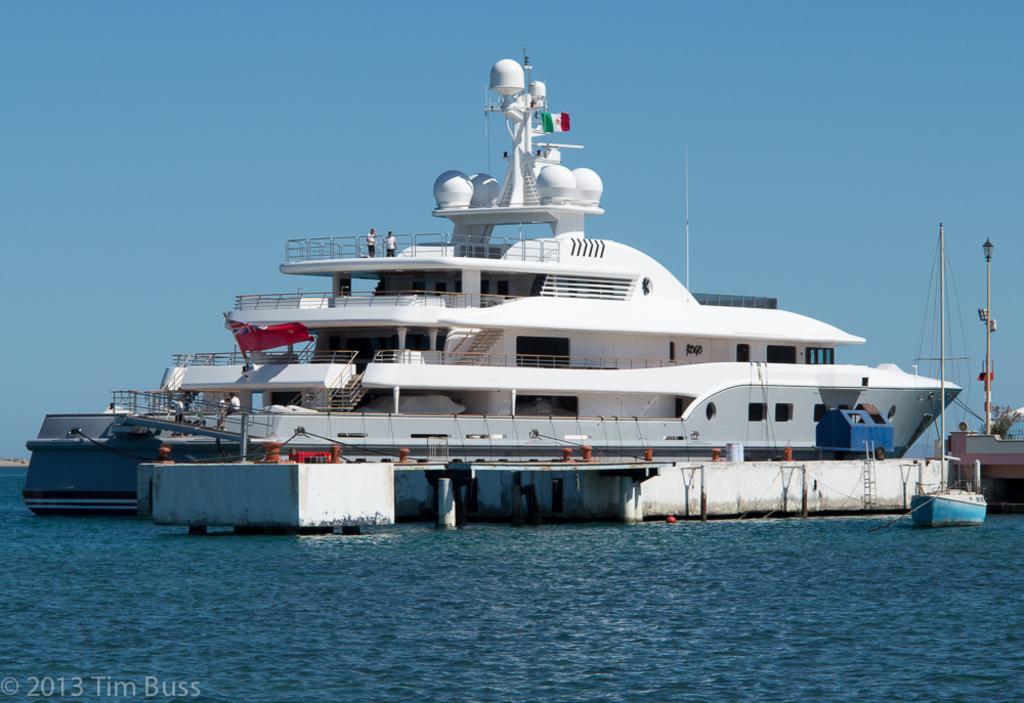In one or two sentences, can you explain what this image depicts? In this image we can see a cruise on the water and person standing on it. In the background we can see sky. 